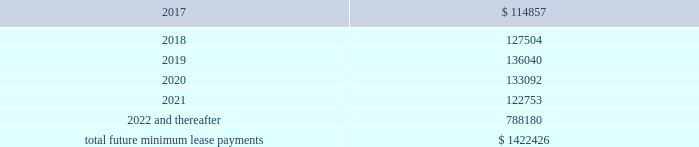Interest expense , net was $ 26.4 million , $ 14.6 million , and $ 5.3 million for the years ended december 31 , 2016 , 2015 and 2014 , respectively .
Interest expense includes the amortization of deferred financing costs , bank fees , capital and built-to-suit lease interest and interest expense under the credit and other long term debt facilities .
Amortization of deferred financing costs was $ 1.2 million , $ 0.8 million , and $ 0.6 million for the years ended december 31 , 2016 , 2015 and 2014 , respectively .
The company monitors the financial health and stability of its lenders under the credit and other long term debt facilities , however during any period of significant instability in the credit markets lenders could be negatively impacted in their ability to perform under these facilities .
Commitments and contingencies obligations under operating leases the company leases warehouse space , office facilities , space for its brand and factory house stores and certain equipment under non-cancelable operating leases .
The leases expire at various dates through 2033 , excluding extensions at the company 2019s option , and include provisions for rental adjustments .
The table below includes executed lease agreements for brand and factory house stores that the company did not yet occupy as of december 31 , 2016 and does not include contingent rent the company may incur at its stores based on future sales above a specified minimum or payments made for maintenance , insurance and real estate taxes .
The following is a schedule of future minimum lease payments for non-cancelable real property operating leases as of december 31 , 2016 as well as significant operating lease agreements entered into during the period after december 31 , 2016 through the date of this report : ( in thousands ) .
Included in selling , general and administrative expense was rent expense of $ 109.0 million , $ 83.0 million and $ 59.0 million for the years ended december 31 , 2016 , 2015 and 2014 , respectively , under non-cancelable operating lease agreements .
Included in these amounts was contingent rent expense of $ 13.0 million , $ 11.0 million and $ 11.0 million for the years ended december 31 , 2016 , 2015 and 2014 , respectively .
Sports marketing and other commitments within the normal course of business , the company enters into contractual commitments in order to promote the company 2019s brand and products .
These commitments include sponsorship agreements with teams and athletes on the collegiate and professional levels , official supplier agreements , athletic event sponsorships and other marketing commitments .
The following is a schedule of the company 2019s future minimum payments under its sponsorship and other marketing agreements as of december 31 .
What percentage change in rent expense from 2015 to 2016? 
Computations: ((109.0 - 83.0) / 83.0)
Answer: 0.31325. 